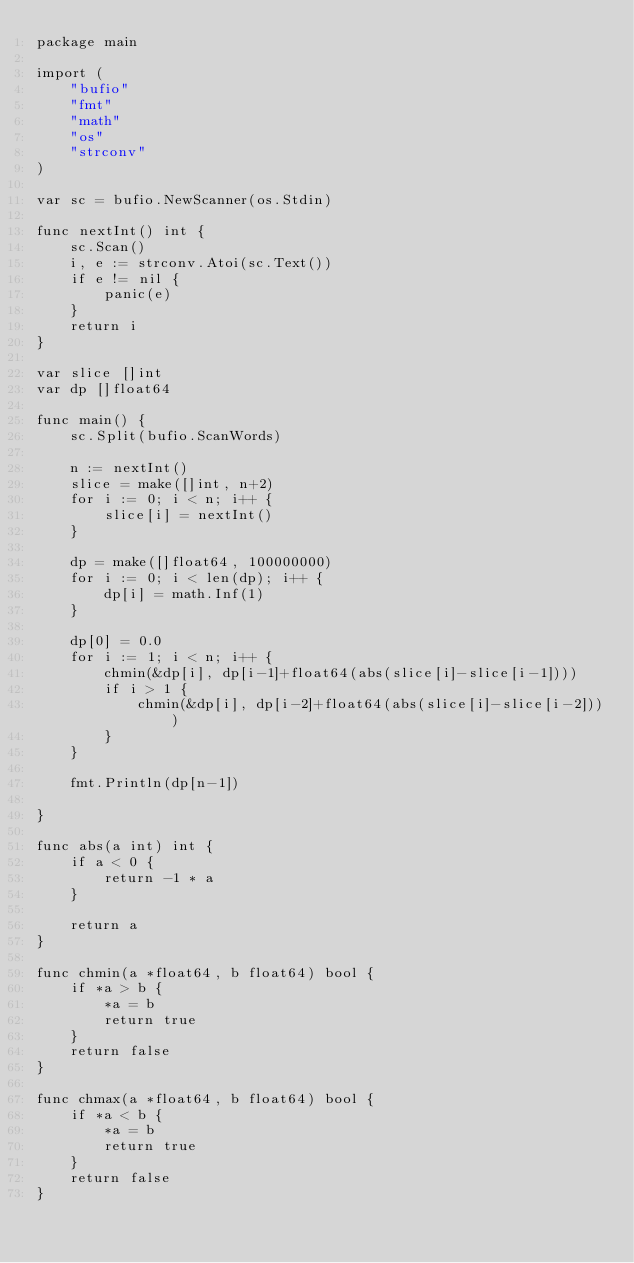<code> <loc_0><loc_0><loc_500><loc_500><_Go_>package main

import (
	"bufio"
	"fmt"
	"math"
	"os"
	"strconv"
)

var sc = bufio.NewScanner(os.Stdin)

func nextInt() int {
	sc.Scan()
	i, e := strconv.Atoi(sc.Text())
	if e != nil {
		panic(e)
	}
	return i
}

var slice []int
var dp []float64

func main() {
	sc.Split(bufio.ScanWords)

	n := nextInt()
	slice = make([]int, n+2)
	for i := 0; i < n; i++ {
		slice[i] = nextInt()
	}

	dp = make([]float64, 100000000)
	for i := 0; i < len(dp); i++ {
		dp[i] = math.Inf(1)
	}

	dp[0] = 0.0
	for i := 1; i < n; i++ {
		chmin(&dp[i], dp[i-1]+float64(abs(slice[i]-slice[i-1])))
		if i > 1 {
			chmin(&dp[i], dp[i-2]+float64(abs(slice[i]-slice[i-2])))
		}
	}

	fmt.Println(dp[n-1])

}

func abs(a int) int {
	if a < 0 {
		return -1 * a
	}

	return a
}

func chmin(a *float64, b float64) bool {
	if *a > b {
		*a = b
		return true
	}
	return false
}

func chmax(a *float64, b float64) bool {
	if *a < b {
		*a = b
		return true
	}
	return false
}
</code> 